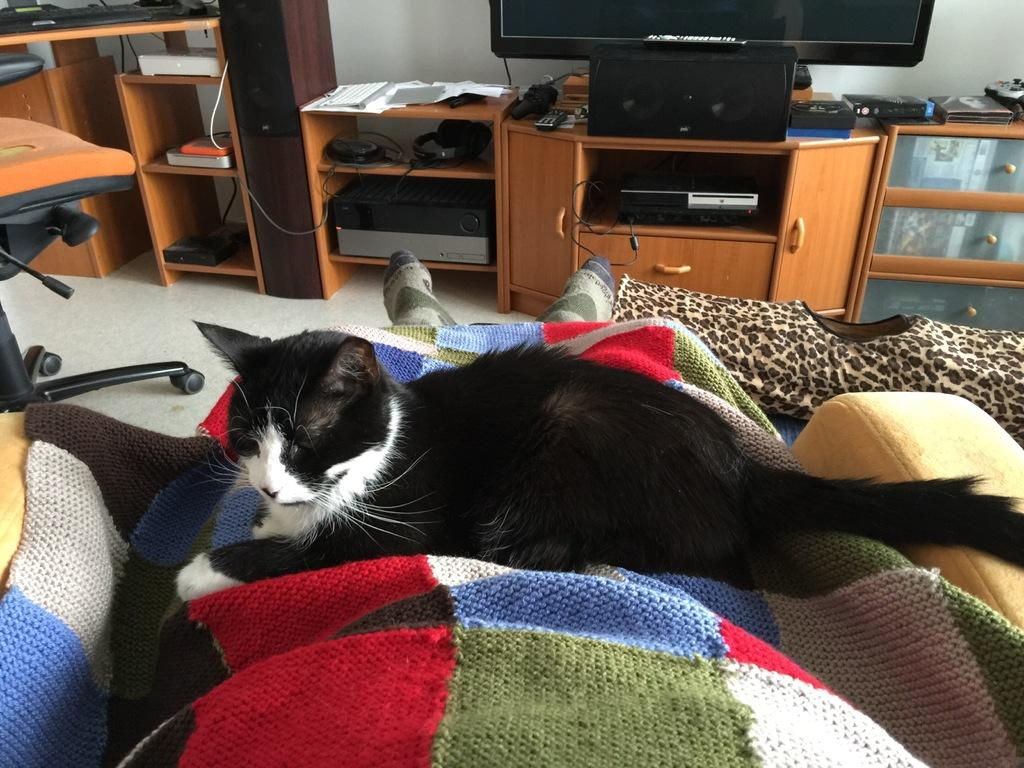What type of animal can be seen in the image? There is a cat in the image. Where is the cat located? The cat is lying on a couch. What other furniture or objects are visible in the image? There is a cupboard in the image. What is on top of the cupboard? A TV is present on the cupboard. What type of field can be seen in the image? There is no field present in the image; it features a cat lying on a couch, a cupboard, and a TV. 